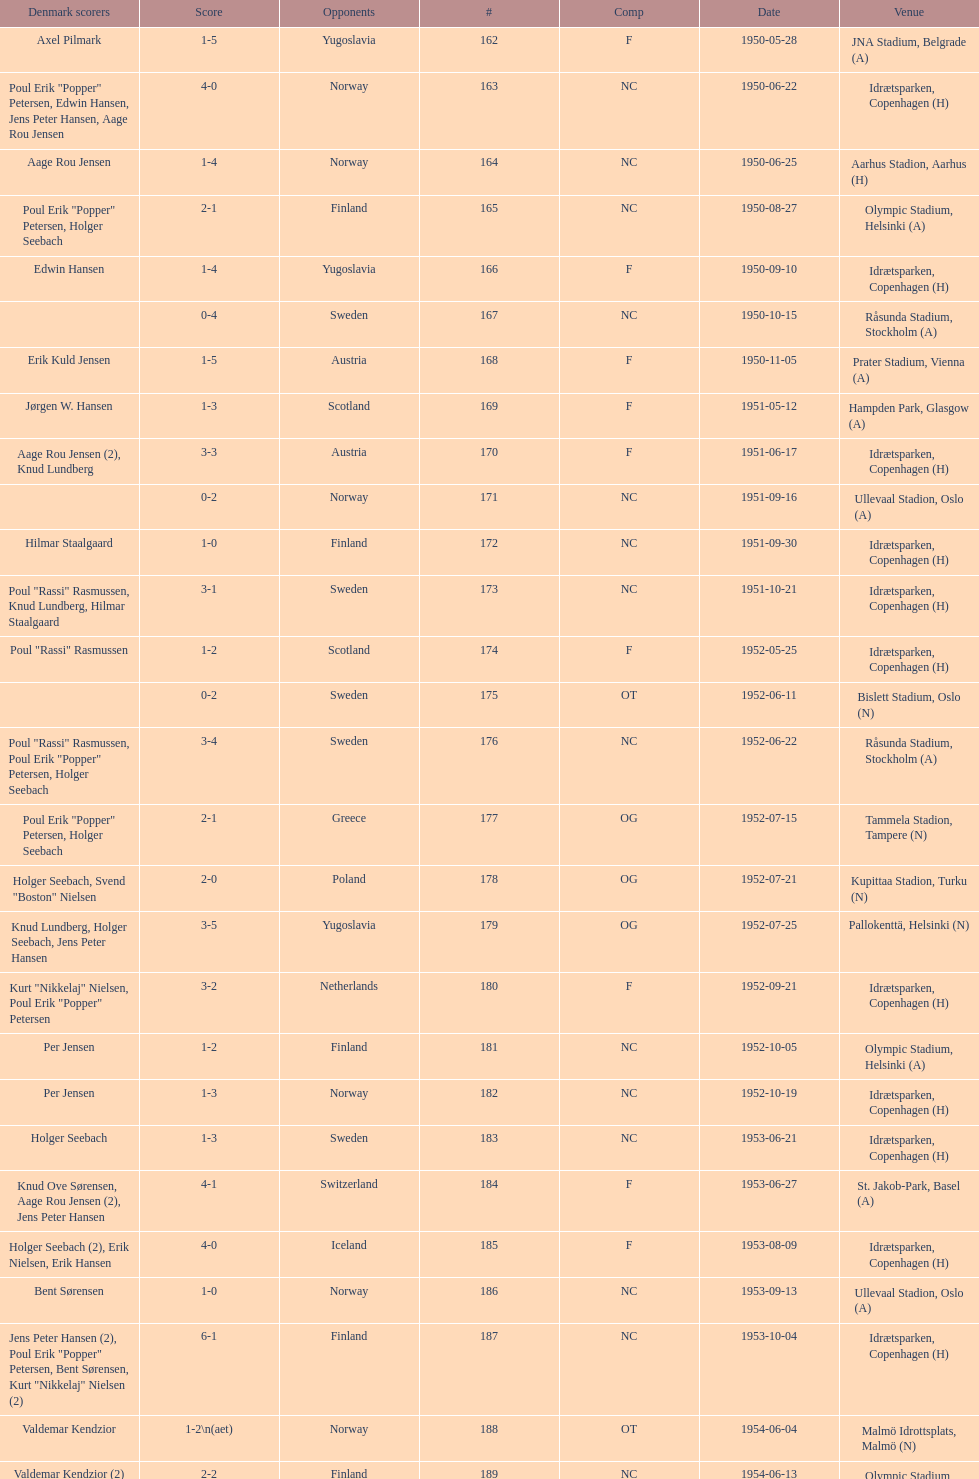What is the designation of the place recorded before olympic stadium on 1950-08-27? Aarhus Stadion, Aarhus. 